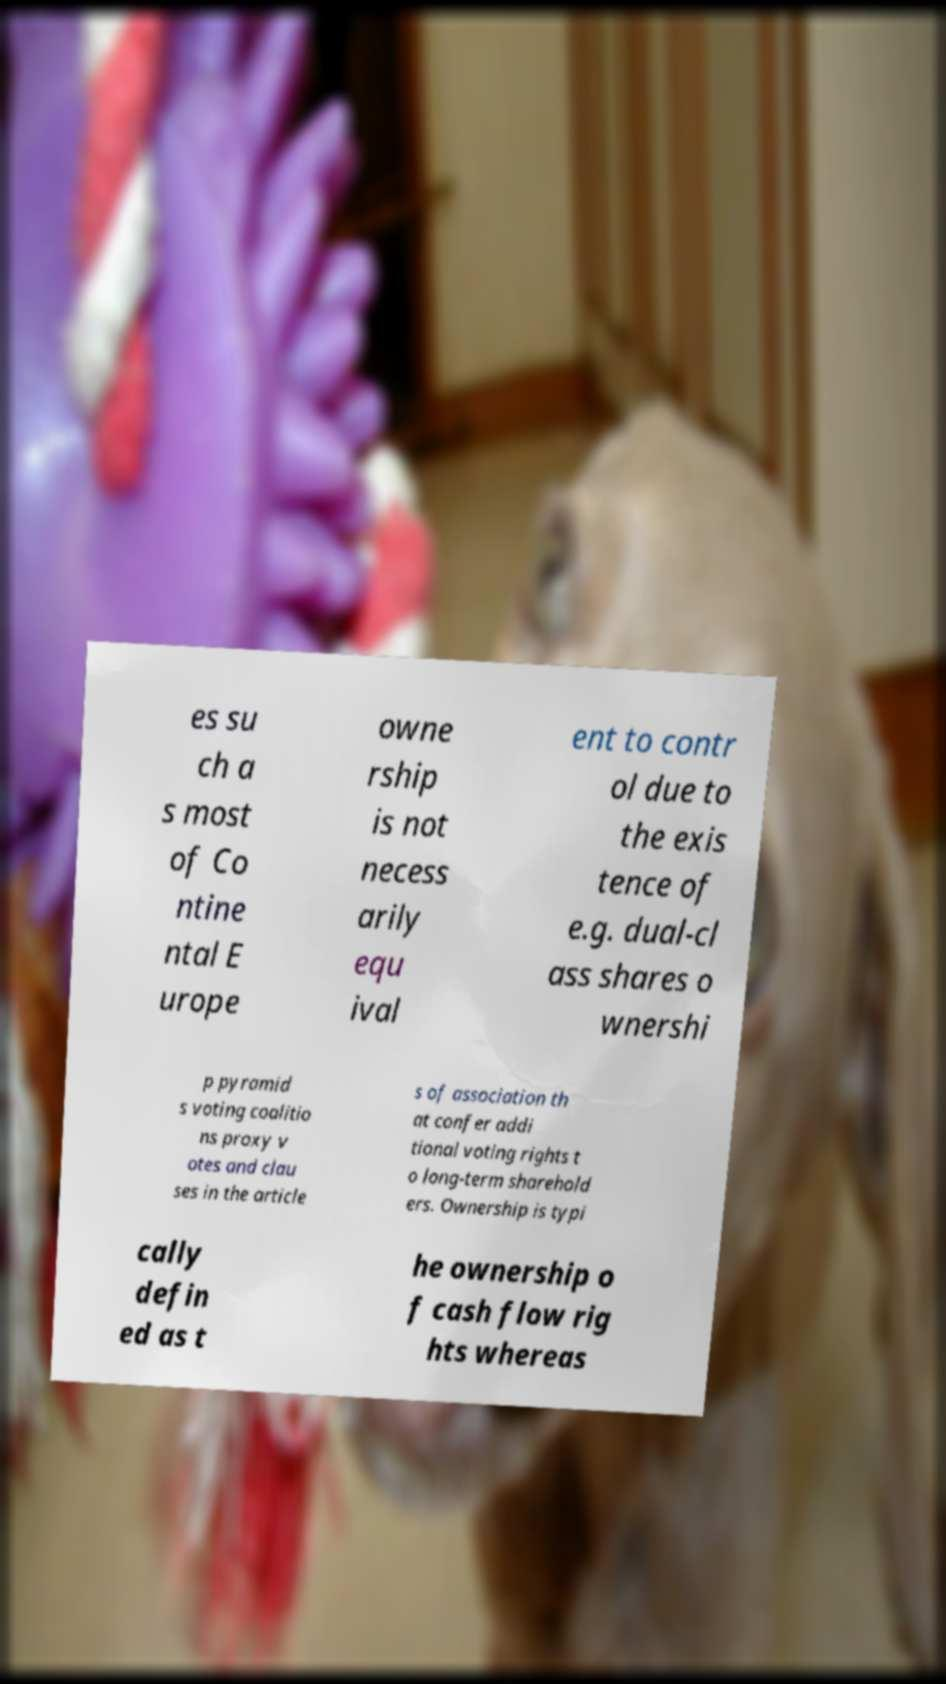There's text embedded in this image that I need extracted. Can you transcribe it verbatim? es su ch a s most of Co ntine ntal E urope owne rship is not necess arily equ ival ent to contr ol due to the exis tence of e.g. dual-cl ass shares o wnershi p pyramid s voting coalitio ns proxy v otes and clau ses in the article s of association th at confer addi tional voting rights t o long-term sharehold ers. Ownership is typi cally defin ed as t he ownership o f cash flow rig hts whereas 